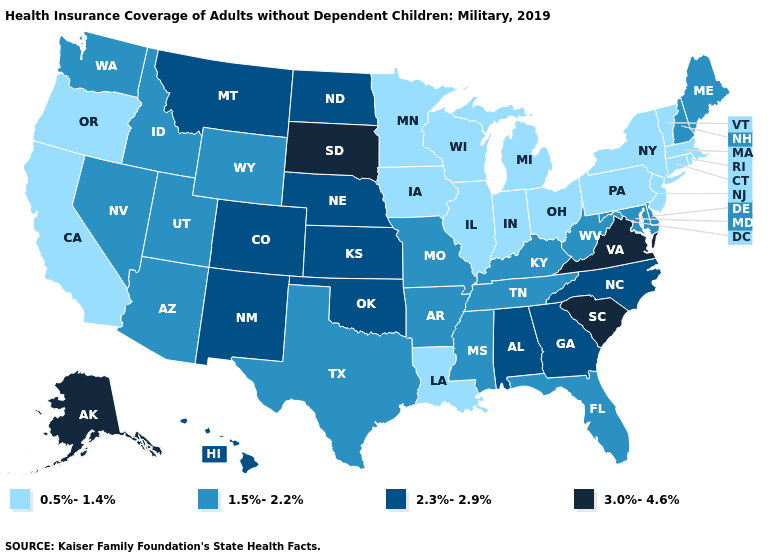Does South Carolina have the highest value in the USA?
Give a very brief answer. Yes. Name the states that have a value in the range 0.5%-1.4%?
Be succinct. California, Connecticut, Illinois, Indiana, Iowa, Louisiana, Massachusetts, Michigan, Minnesota, New Jersey, New York, Ohio, Oregon, Pennsylvania, Rhode Island, Vermont, Wisconsin. What is the value of Oklahoma?
Be succinct. 2.3%-2.9%. What is the value of North Dakota?
Give a very brief answer. 2.3%-2.9%. Does Hawaii have the lowest value in the West?
Keep it brief. No. Among the states that border Mississippi , does Tennessee have the lowest value?
Quick response, please. No. Does Alaska have the highest value in the West?
Quick response, please. Yes. Among the states that border Delaware , does Maryland have the lowest value?
Give a very brief answer. No. Does South Dakota have the highest value in the MidWest?
Answer briefly. Yes. Does the first symbol in the legend represent the smallest category?
Write a very short answer. Yes. What is the highest value in the USA?
Give a very brief answer. 3.0%-4.6%. Name the states that have a value in the range 3.0%-4.6%?
Concise answer only. Alaska, South Carolina, South Dakota, Virginia. Which states have the lowest value in the USA?
Quick response, please. California, Connecticut, Illinois, Indiana, Iowa, Louisiana, Massachusetts, Michigan, Minnesota, New Jersey, New York, Ohio, Oregon, Pennsylvania, Rhode Island, Vermont, Wisconsin. What is the highest value in the MidWest ?
Keep it brief. 3.0%-4.6%. What is the value of Connecticut?
Answer briefly. 0.5%-1.4%. 